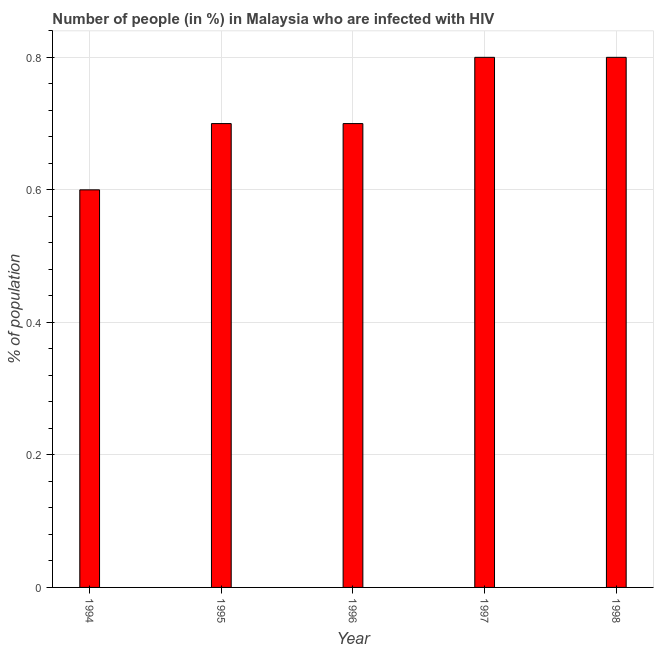Does the graph contain any zero values?
Provide a succinct answer. No. What is the title of the graph?
Keep it short and to the point. Number of people (in %) in Malaysia who are infected with HIV. What is the label or title of the Y-axis?
Provide a short and direct response. % of population. What is the sum of the number of people infected with hiv?
Your answer should be compact. 3.6. What is the average number of people infected with hiv per year?
Ensure brevity in your answer.  0.72. What is the median number of people infected with hiv?
Provide a short and direct response. 0.7. In how many years, is the number of people infected with hiv greater than 0.12 %?
Your answer should be very brief. 5. Do a majority of the years between 1994 and 1997 (inclusive) have number of people infected with hiv greater than 0.56 %?
Offer a terse response. Yes. Is the number of people infected with hiv in 1995 less than that in 1998?
Your response must be concise. Yes. Is the difference between the number of people infected with hiv in 1995 and 1996 greater than the difference between any two years?
Make the answer very short. No. What is the difference between the highest and the second highest number of people infected with hiv?
Give a very brief answer. 0. What is the difference between the highest and the lowest number of people infected with hiv?
Your answer should be compact. 0.2. In how many years, is the number of people infected with hiv greater than the average number of people infected with hiv taken over all years?
Offer a terse response. 2. How many bars are there?
Provide a succinct answer. 5. Are the values on the major ticks of Y-axis written in scientific E-notation?
Give a very brief answer. No. What is the % of population of 1995?
Provide a succinct answer. 0.7. What is the difference between the % of population in 1994 and 1995?
Offer a very short reply. -0.1. What is the difference between the % of population in 1994 and 1996?
Provide a succinct answer. -0.1. What is the difference between the % of population in 1995 and 1996?
Your answer should be compact. 0. What is the difference between the % of population in 1995 and 1997?
Keep it short and to the point. -0.1. What is the difference between the % of population in 1995 and 1998?
Your response must be concise. -0.1. What is the difference between the % of population in 1997 and 1998?
Offer a terse response. 0. What is the ratio of the % of population in 1994 to that in 1995?
Provide a succinct answer. 0.86. What is the ratio of the % of population in 1994 to that in 1996?
Provide a short and direct response. 0.86. What is the ratio of the % of population in 1994 to that in 1997?
Ensure brevity in your answer.  0.75. What is the ratio of the % of population in 1994 to that in 1998?
Provide a succinct answer. 0.75. What is the ratio of the % of population in 1995 to that in 1996?
Offer a terse response. 1. What is the ratio of the % of population in 1995 to that in 1997?
Keep it short and to the point. 0.88. What is the ratio of the % of population in 1995 to that in 1998?
Provide a succinct answer. 0.88. What is the ratio of the % of population in 1997 to that in 1998?
Your answer should be compact. 1. 